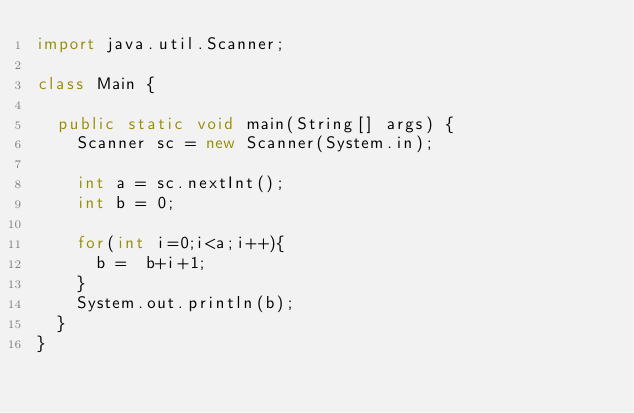<code> <loc_0><loc_0><loc_500><loc_500><_Java_>import java.util.Scanner;

class Main {

	public static void main(String[] args) {
		Scanner sc = new Scanner(System.in);

		int a = sc.nextInt();
		int b = 0;

		for(int i=0;i<a;i++){
			b =  b+i+1;
		}
		System.out.println(b);
	}
}</code> 